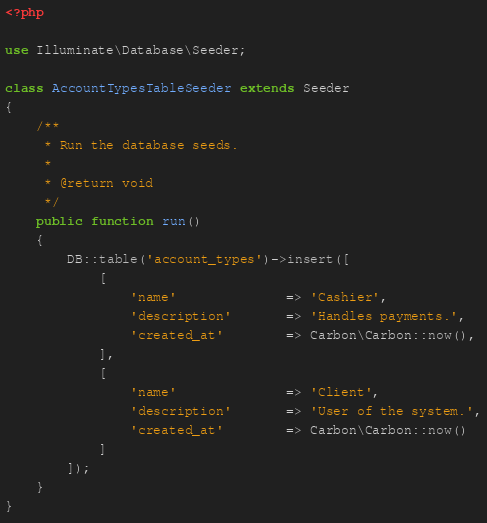Convert code to text. <code><loc_0><loc_0><loc_500><loc_500><_PHP_><?php

use Illuminate\Database\Seeder;

class AccountTypesTableSeeder extends Seeder
{
    /**
     * Run the database seeds.
     *
     * @return void
     */
    public function run()
    {
        DB::table('account_types')->insert([
            [
                'name'              => 'Cashier',
                'description'       => 'Handles payments.',
                'created_at'        => Carbon\Carbon::now(),
            ],
            [
                'name'              => 'Client',
                'description'       => 'User of the system.',
                'created_at'        => Carbon\Carbon::now()
            ]
        ]);
    }
}
</code> 